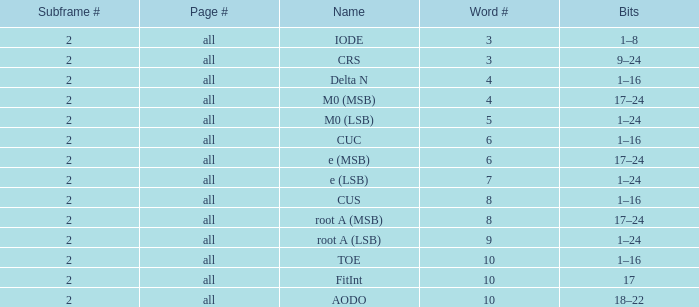What is the average word count with crs and subframes lesser than 2? None. Would you be able to parse every entry in this table? {'header': ['Subframe #', 'Page #', 'Name', 'Word #', 'Bits'], 'rows': [['2', 'all', 'IODE', '3', '1–8'], ['2', 'all', 'CRS', '3', '9–24'], ['2', 'all', 'Delta N', '4', '1–16'], ['2', 'all', 'M0 (MSB)', '4', '17–24'], ['2', 'all', 'M0 (LSB)', '5', '1–24'], ['2', 'all', 'CUC', '6', '1–16'], ['2', 'all', 'e (MSB)', '6', '17–24'], ['2', 'all', 'e (LSB)', '7', '1–24'], ['2', 'all', 'CUS', '8', '1–16'], ['2', 'all', 'root A (MSB)', '8', '17–24'], ['2', 'all', 'root A (LSB)', '9', '1–24'], ['2', 'all', 'TOE', '10', '1–16'], ['2', 'all', 'FitInt', '10', '17'], ['2', 'all', 'AODO', '10', '18–22']]} 